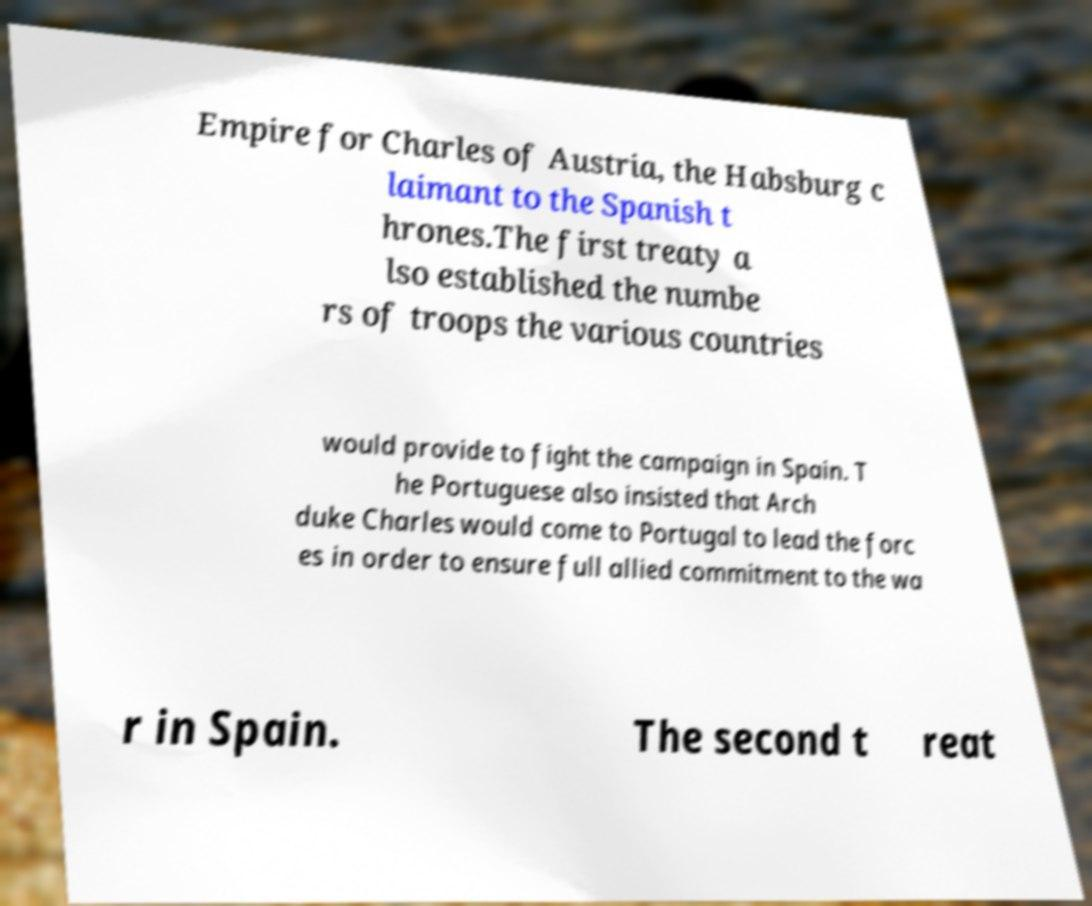For documentation purposes, I need the text within this image transcribed. Could you provide that? Empire for Charles of Austria, the Habsburg c laimant to the Spanish t hrones.The first treaty a lso established the numbe rs of troops the various countries would provide to fight the campaign in Spain. T he Portuguese also insisted that Arch duke Charles would come to Portugal to lead the forc es in order to ensure full allied commitment to the wa r in Spain. The second t reat 